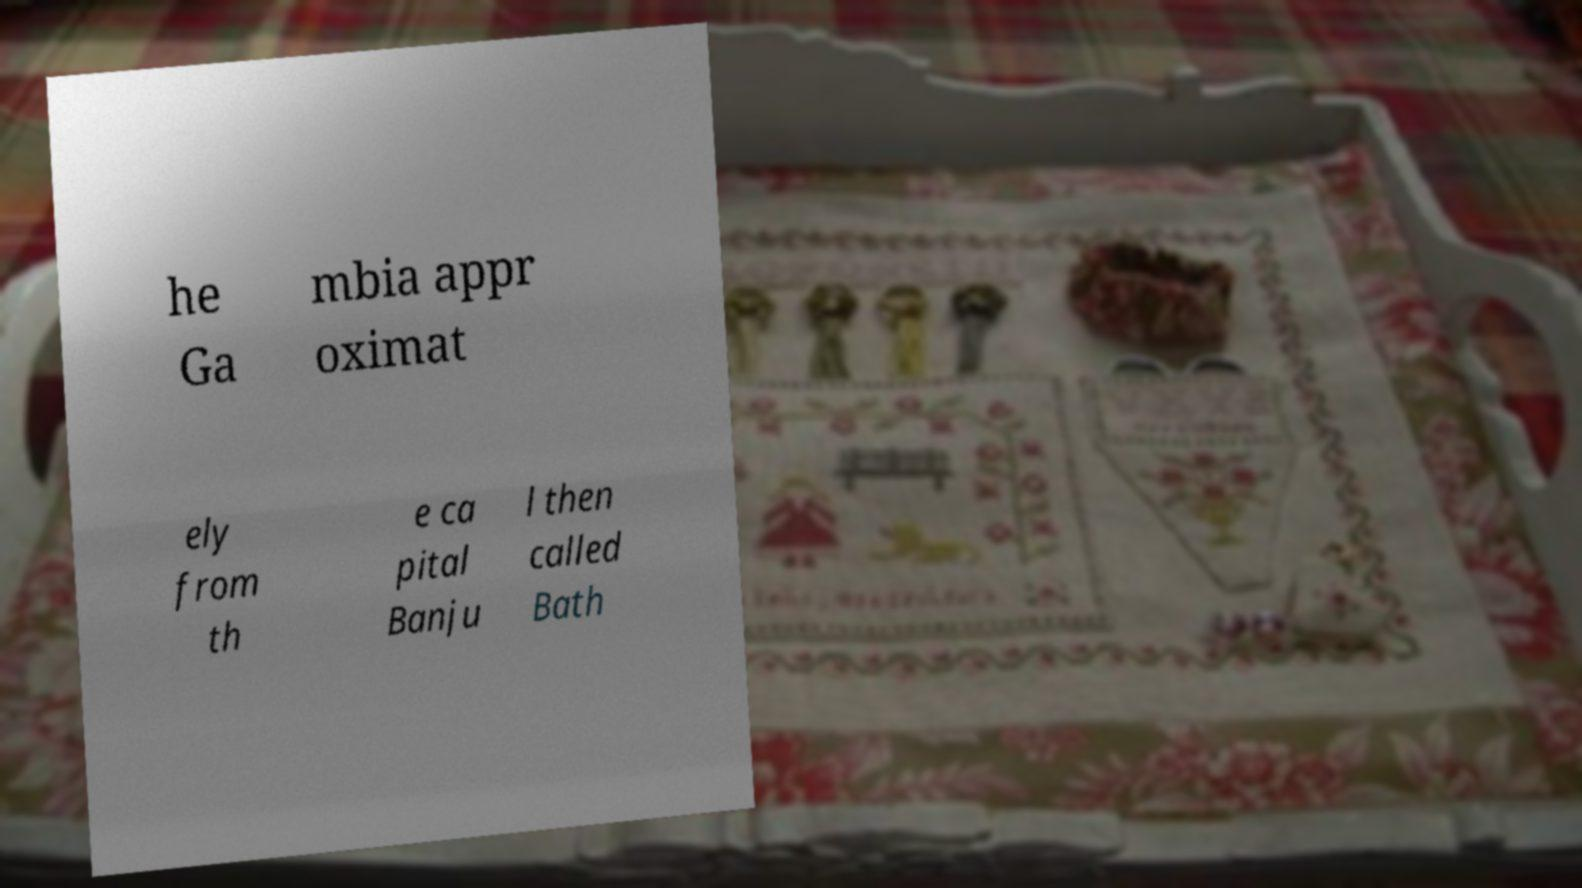There's text embedded in this image that I need extracted. Can you transcribe it verbatim? he Ga mbia appr oximat ely from th e ca pital Banju l then called Bath 